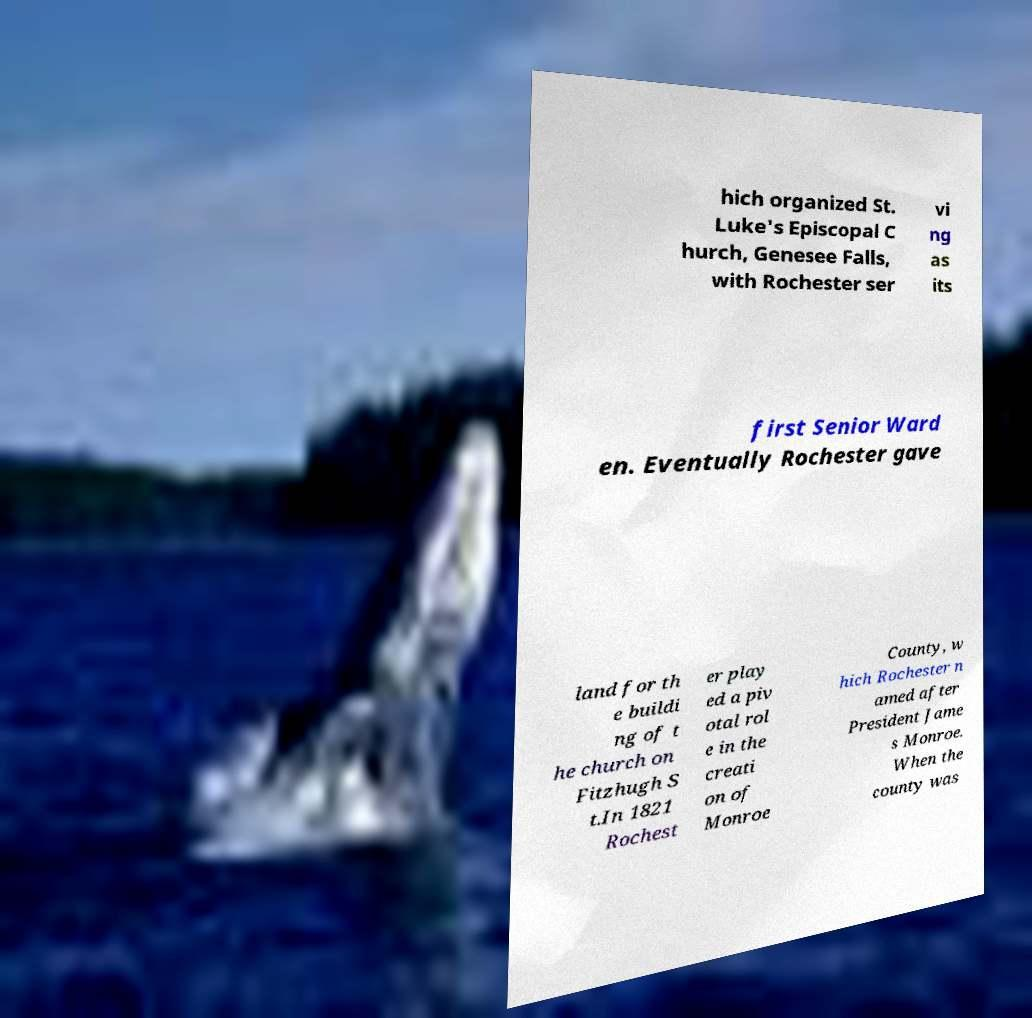Can you accurately transcribe the text from the provided image for me? hich organized St. Luke's Episcopal C hurch, Genesee Falls, with Rochester ser vi ng as its first Senior Ward en. Eventually Rochester gave land for th e buildi ng of t he church on Fitzhugh S t.In 1821 Rochest er play ed a piv otal rol e in the creati on of Monroe County, w hich Rochester n amed after President Jame s Monroe. When the county was 